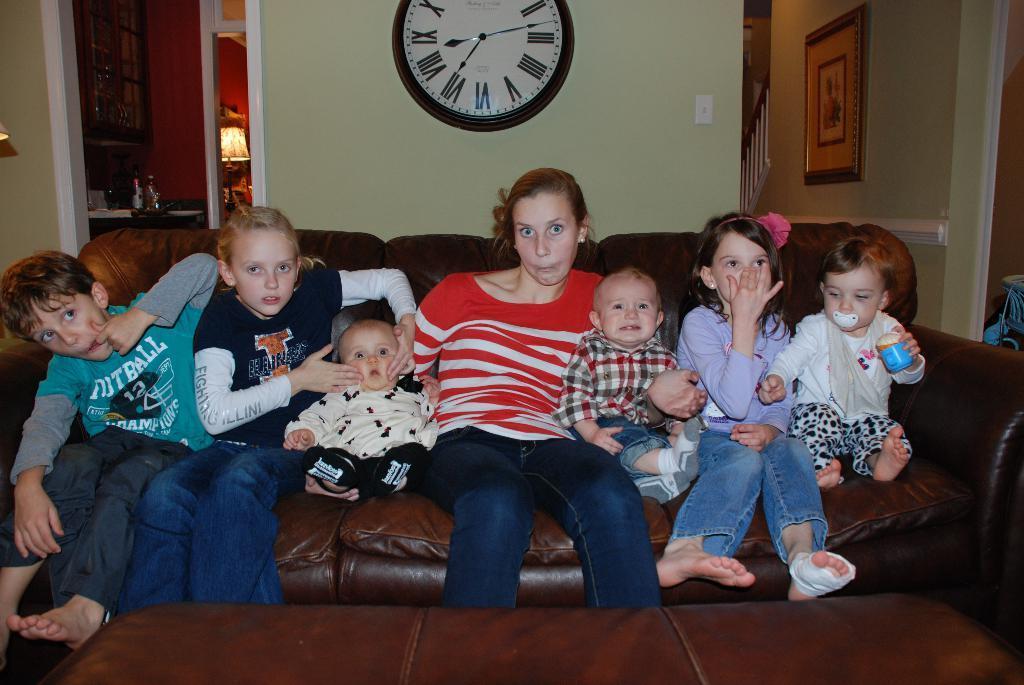Describe this image in one or two sentences. In this image we can see a woman sitting on a sofa and she is in the center. Here we can see two girls sitting on the sofa. Here we can see a boy on the left side. Here we can see the babies on the sofa. Here we can see the clock on the wall. Here we can see a photo frame on the wall and it is on the right side. Here we can see the table lamp on the left side. 